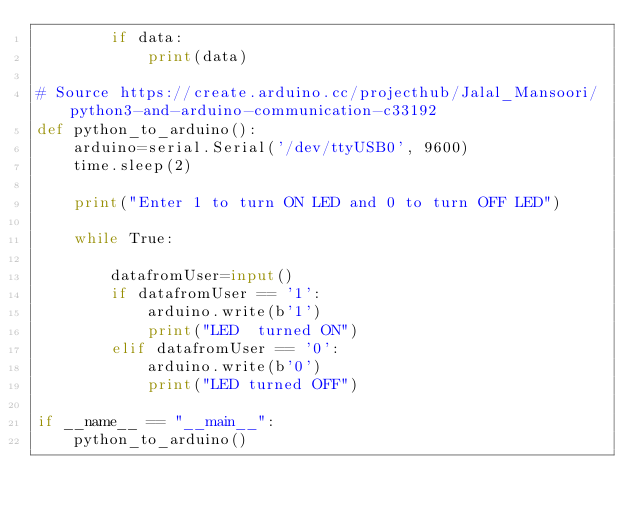<code> <loc_0><loc_0><loc_500><loc_500><_Python_>        if data:
            print(data)

# Source https://create.arduino.cc/projecthub/Jalal_Mansoori/python3-and-arduino-communication-c33192
def python_to_arduino():
    arduino=serial.Serial('/dev/ttyUSB0', 9600)
    time.sleep(2)

    print("Enter 1 to turn ON LED and 0 to turn OFF LED")

    while True:
        
        datafromUser=input()
        if datafromUser == '1':
            arduino.write(b'1')
            print("LED  turned ON")
        elif datafromUser == '0':
            arduino.write(b'0')
            print("LED turned OFF")

if __name__ == "__main__":
    python_to_arduino()
</code> 